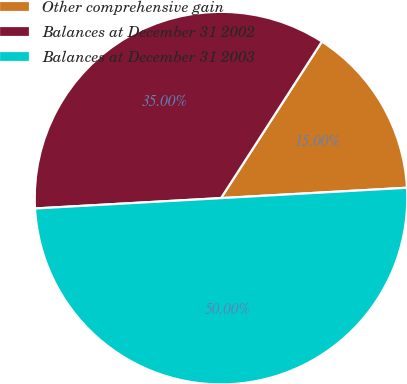Convert chart. <chart><loc_0><loc_0><loc_500><loc_500><pie_chart><fcel>Other comprehensive gain<fcel>Balances at December 31 2002<fcel>Balances at December 31 2003<nl><fcel>15.0%<fcel>35.0%<fcel>50.0%<nl></chart> 